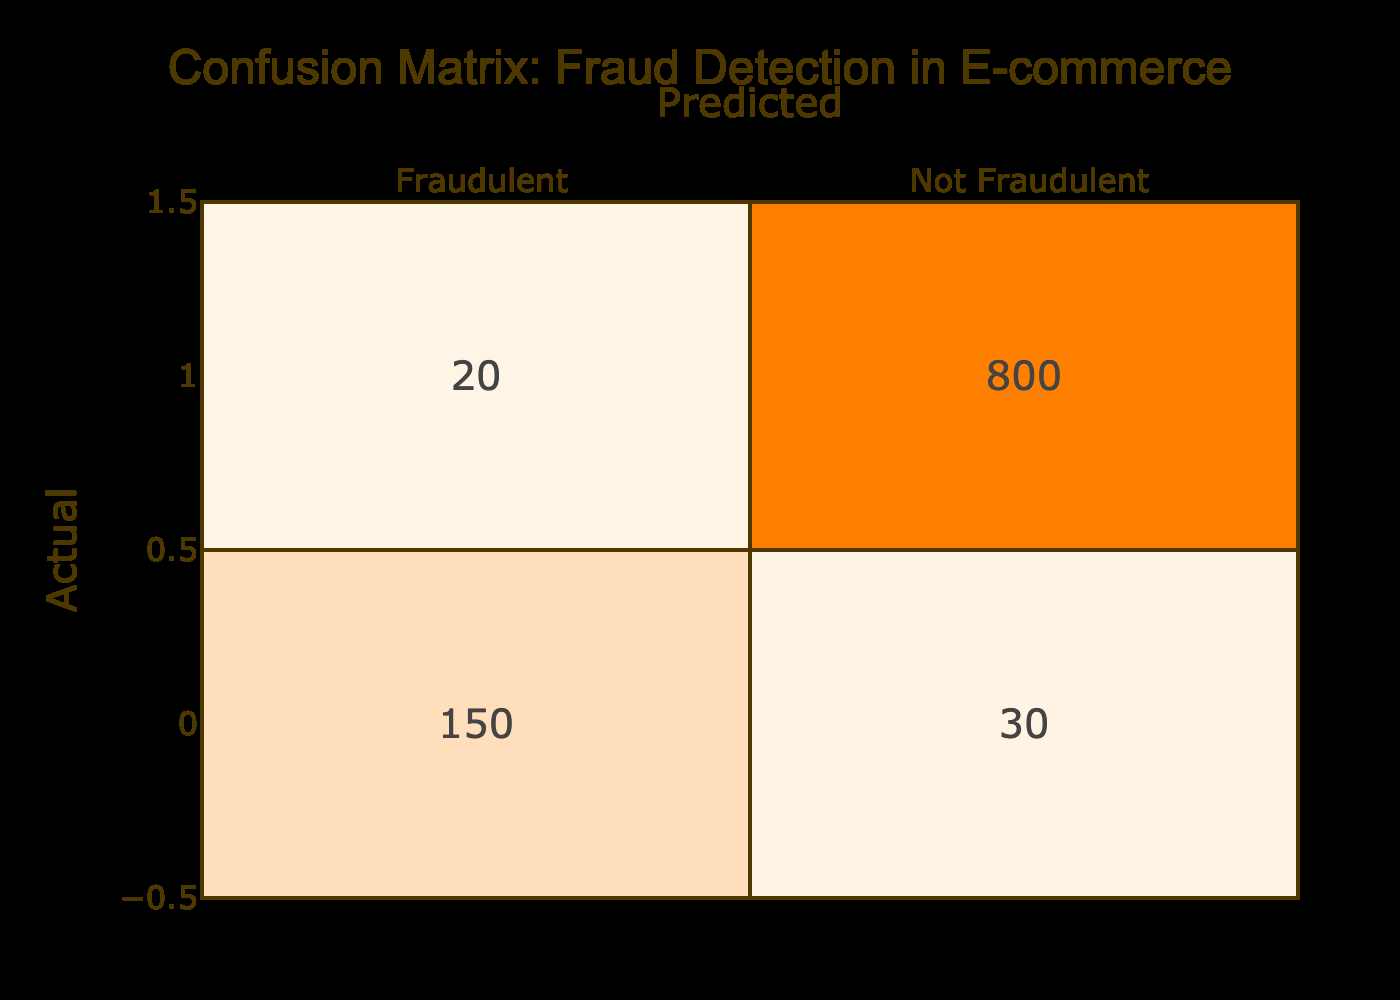What is the number of fraudulent transactions that were correctly identified? The correct identification of fraudulent transactions corresponds to the cell where actual fraudulent cases intersect with predicted fraudulent cases, which has a value of 150.
Answer: 150 What is the total number of not fraudulent transactions? The total number of not fraudulent transactions is obtained by adding the number of actual not fraudulent cases (800) to the number of fraudulent cases incorrectly predicted as not fraudulent (20). This gives us 800 + 20 = 820.
Answer: 820 Was the fraud detection model better at identifying fraudulent or not fraudulent transactions? By comparing the numbers, the model identified 150 fraudulent cases correctly, while it identified 800 not fraudulent cases correctly. Since 800 > 150, the model was better at identifying not fraudulent transactions.
Answer: Yes, better at identifying not fraudulent transactions What is the total number of fraudulent transactions in this dataset? The total number of fraudulent transactions can be calculated by adding the correctly identified fraudulent transactions (150) and the incorrectly classified fraudulent transactions (20), resulting in 150 + 30 = 180.
Answer: 180 What percentage of fraudulent transactions were actually identified by the model? The percentage can be calculated by taking the correctly identified fraudulent transactions (150) and dividing by the total number of fraudulent transactions (180). The calculation is (150/180) * 100 = 83.33%.
Answer: 83.33% What is the difference between the number of incorrect predictions for fraudulent and not fraudulent transactions? The number of incorrect predictions for fraudulent transactions is 30 and for not fraudulent transactions is 20. To find the difference, we subtract: 30 - 20 = 10.
Answer: 10 Is the number of false negatives greater than the number of false positives? False negatives refer to the actual fraudulent transactions incorrectly predicted as not fraudulent (20), while false positives refer to actual not fraudulent transactions incorrectly predicted as fraudulent (30). Since 30 > 20, the answer is yes.
Answer: Yes What is the overall accuracy of the fraud detection model? The overall accuracy can be calculated by adding the correctly identified transactions (150 + 800 = 950) and dividing this by the total number of transactions (150 + 30 + 20 + 800 = 1000), yielding 950/1000 = 0.95 or 95%.
Answer: 95% 